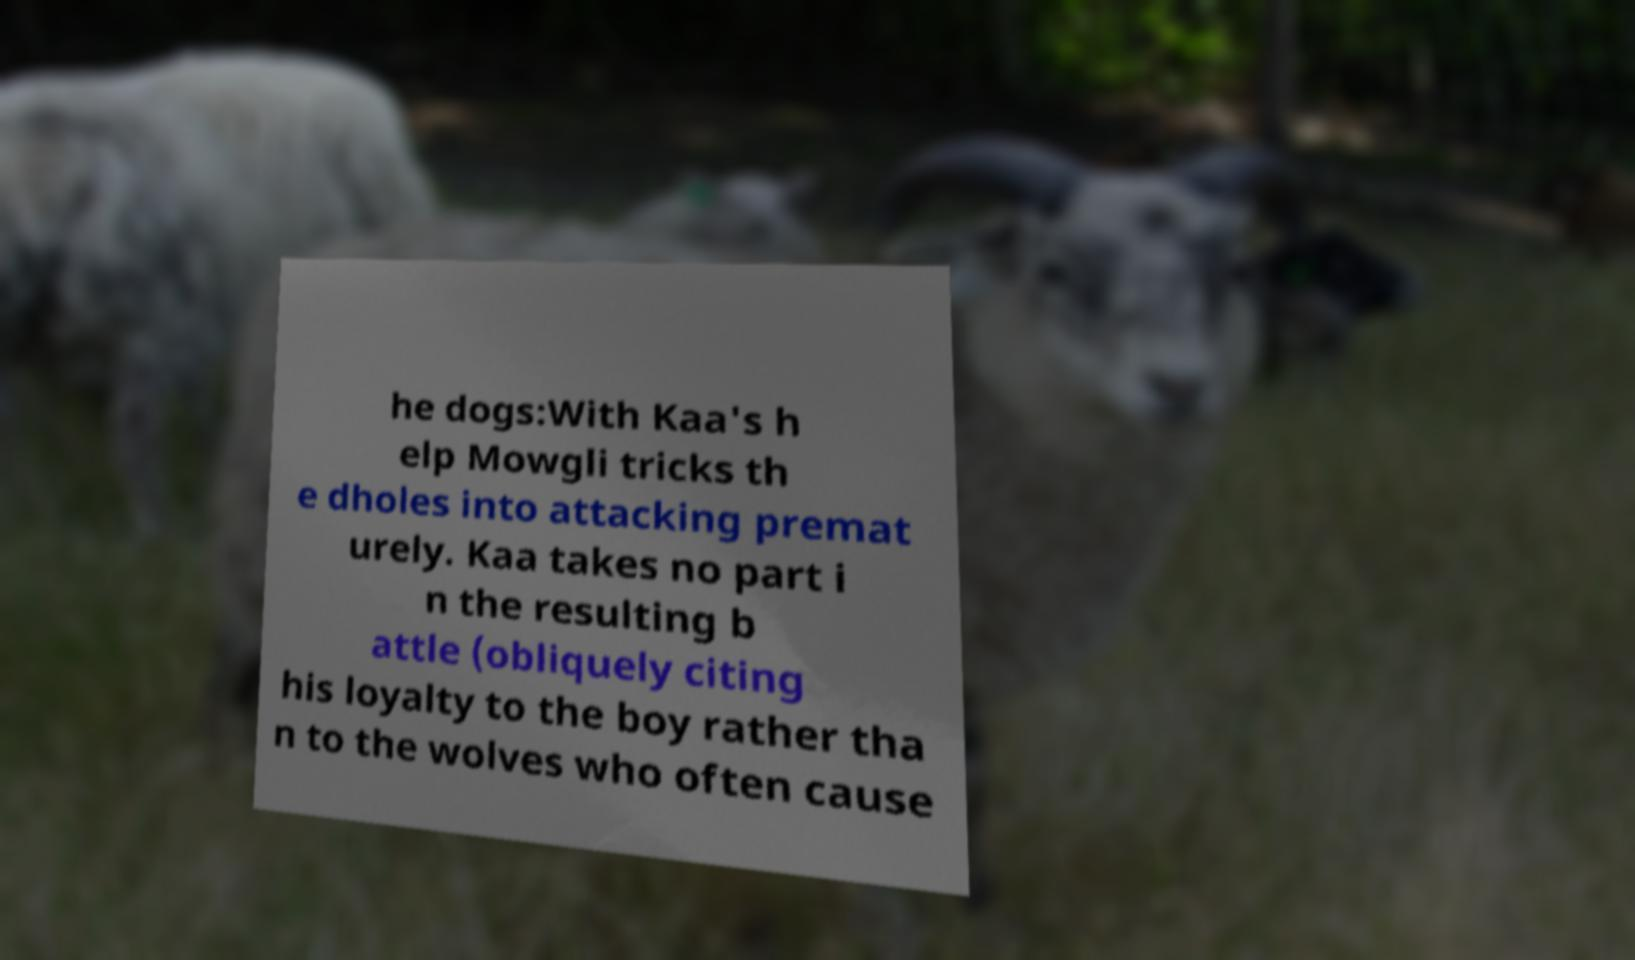Can you read and provide the text displayed in the image?This photo seems to have some interesting text. Can you extract and type it out for me? he dogs:With Kaa's h elp Mowgli tricks th e dholes into attacking premat urely. Kaa takes no part i n the resulting b attle (obliquely citing his loyalty to the boy rather tha n to the wolves who often cause 